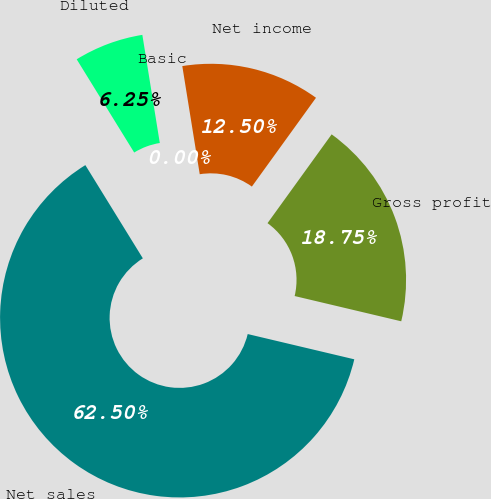Convert chart. <chart><loc_0><loc_0><loc_500><loc_500><pie_chart><fcel>Net sales<fcel>Gross profit<fcel>Net income<fcel>Basic<fcel>Diluted<nl><fcel>62.5%<fcel>18.75%<fcel>12.5%<fcel>0.0%<fcel>6.25%<nl></chart> 